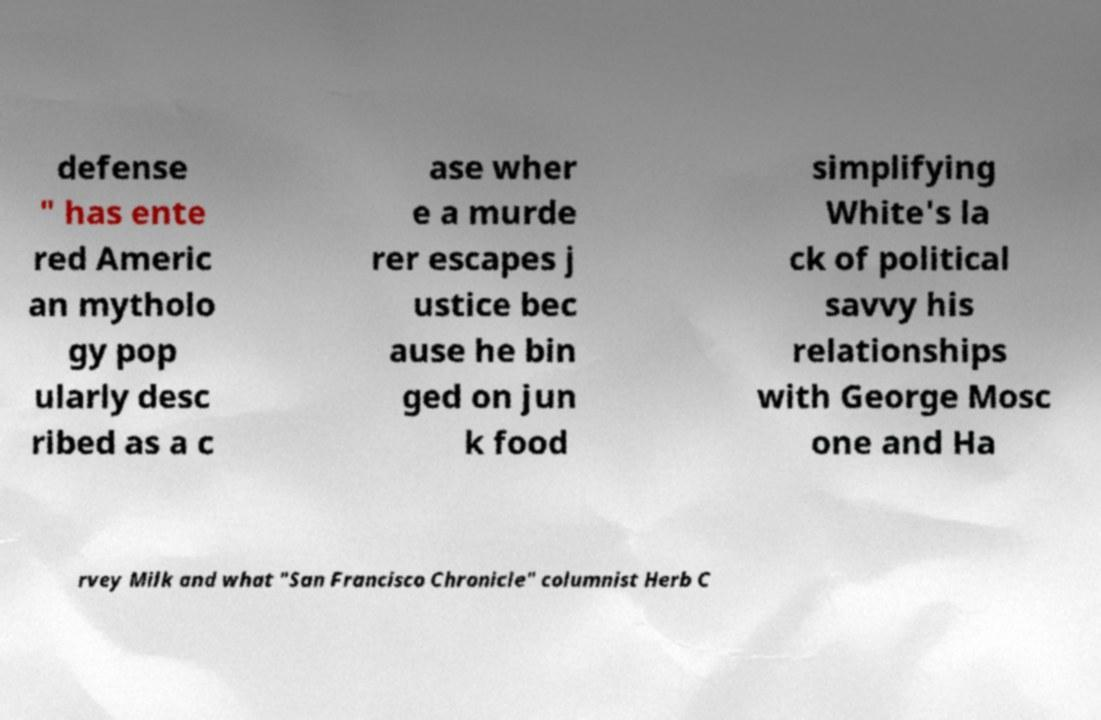For documentation purposes, I need the text within this image transcribed. Could you provide that? defense " has ente red Americ an mytholo gy pop ularly desc ribed as a c ase wher e a murde rer escapes j ustice bec ause he bin ged on jun k food simplifying White's la ck of political savvy his relationships with George Mosc one and Ha rvey Milk and what "San Francisco Chronicle" columnist Herb C 